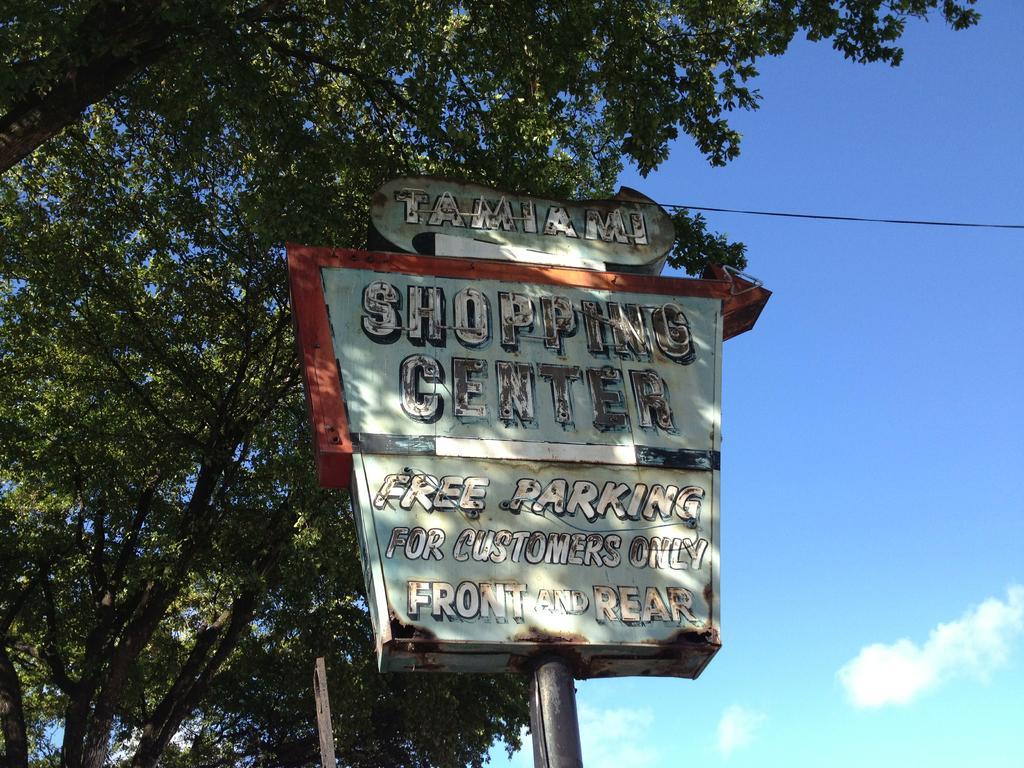In one or two sentences, can you explain what this image depicts? In this image there is a sign board, on that board there is some text, in the background there are trees and the sky. 